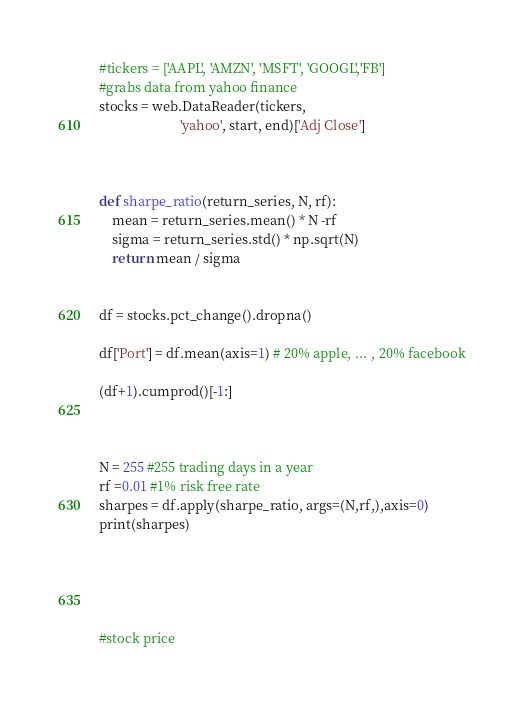Convert code to text. <code><loc_0><loc_0><loc_500><loc_500><_Python_>#tickers = ['AAPL', 'AMZN', 'MSFT', 'GOOGL','FB']
#grabs data from yahoo finance
stocks = web.DataReader(tickers,
                        'yahoo', start, end)['Adj Close']



def sharpe_ratio(return_series, N, rf):
    mean = return_series.mean() * N -rf
    sigma = return_series.std() * np.sqrt(N)
    return mean / sigma


df = stocks.pct_change().dropna()

df['Port'] = df.mean(axis=1) # 20% apple, ... , 20% facebook

(df+1).cumprod()[-1:]



N = 255 #255 trading days in a year
rf =0.01 #1% risk free rate
sharpes = df.apply(sharpe_ratio, args=(N,rf,),axis=0)
print(sharpes)





#stock price</code> 